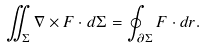Convert formula to latex. <formula><loc_0><loc_0><loc_500><loc_500>\iint _ { \Sigma } \nabla \times F \cdot d \Sigma = \oint _ { \partial \Sigma } F \cdot d r .</formula> 